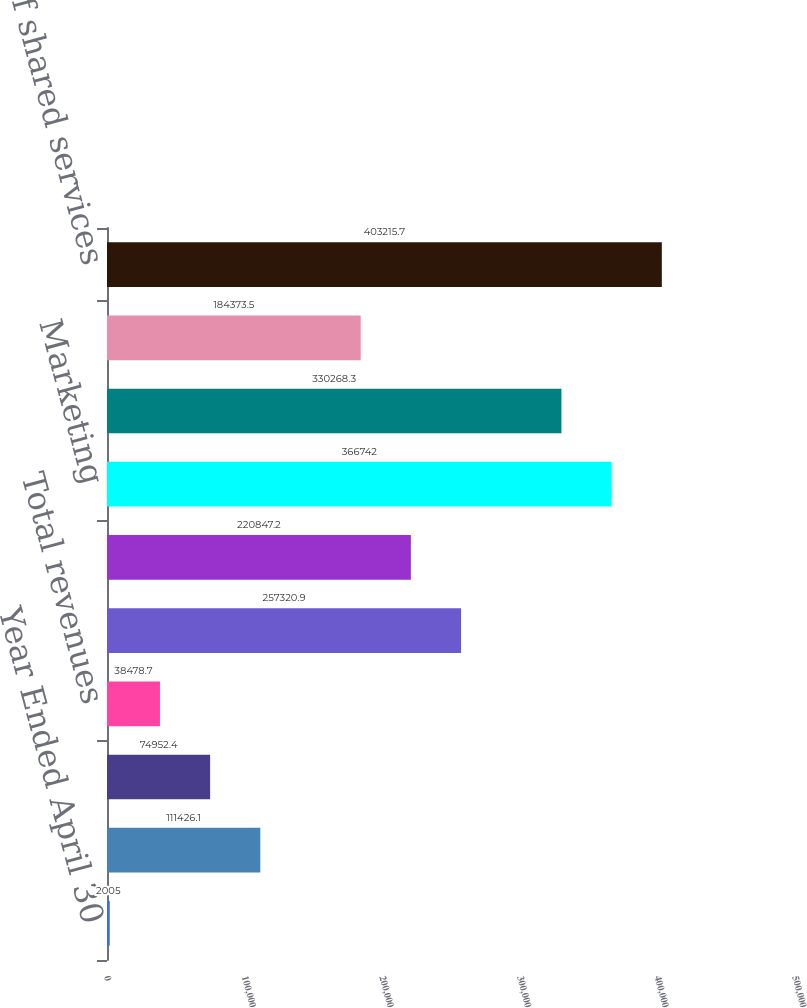Convert chart. <chart><loc_0><loc_0><loc_500><loc_500><bar_chart><fcel>Year Ended April 30<fcel>Operating revenues<fcel>Eliminations<fcel>Total revenues<fcel>Interest expense<fcel>Other<fcel>Marketing<fcel>Information technology<fcel>Finance<fcel>Allocation of shared services<nl><fcel>2005<fcel>111426<fcel>74952.4<fcel>38478.7<fcel>257321<fcel>220847<fcel>366742<fcel>330268<fcel>184374<fcel>403216<nl></chart> 